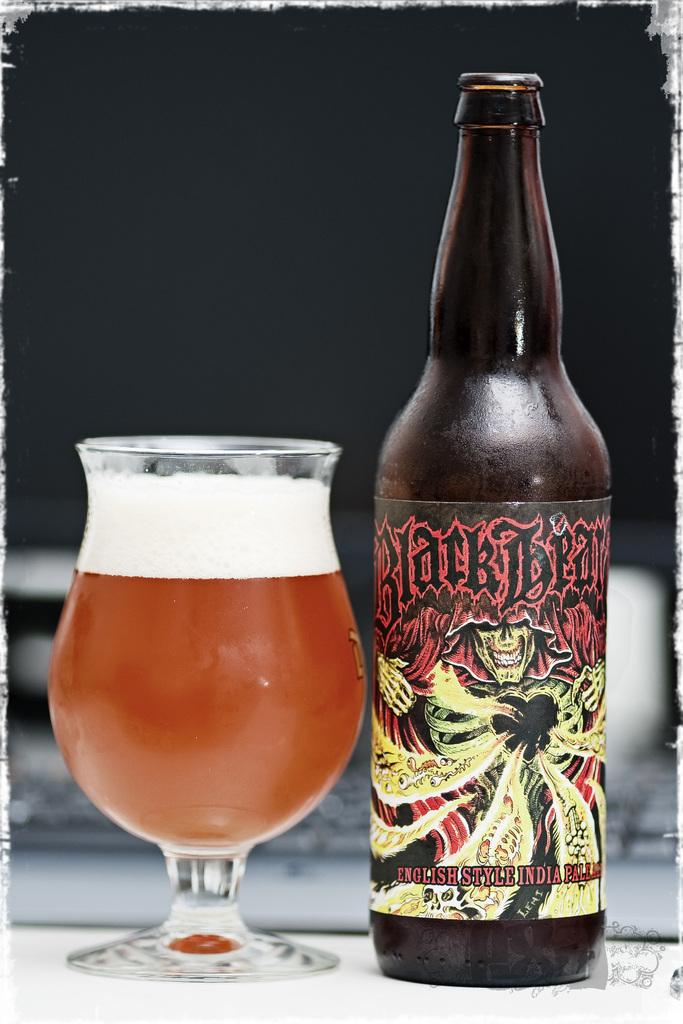<image>
Create a compact narrative representing the image presented. An English style IPA is in a glass next to its bottle. 